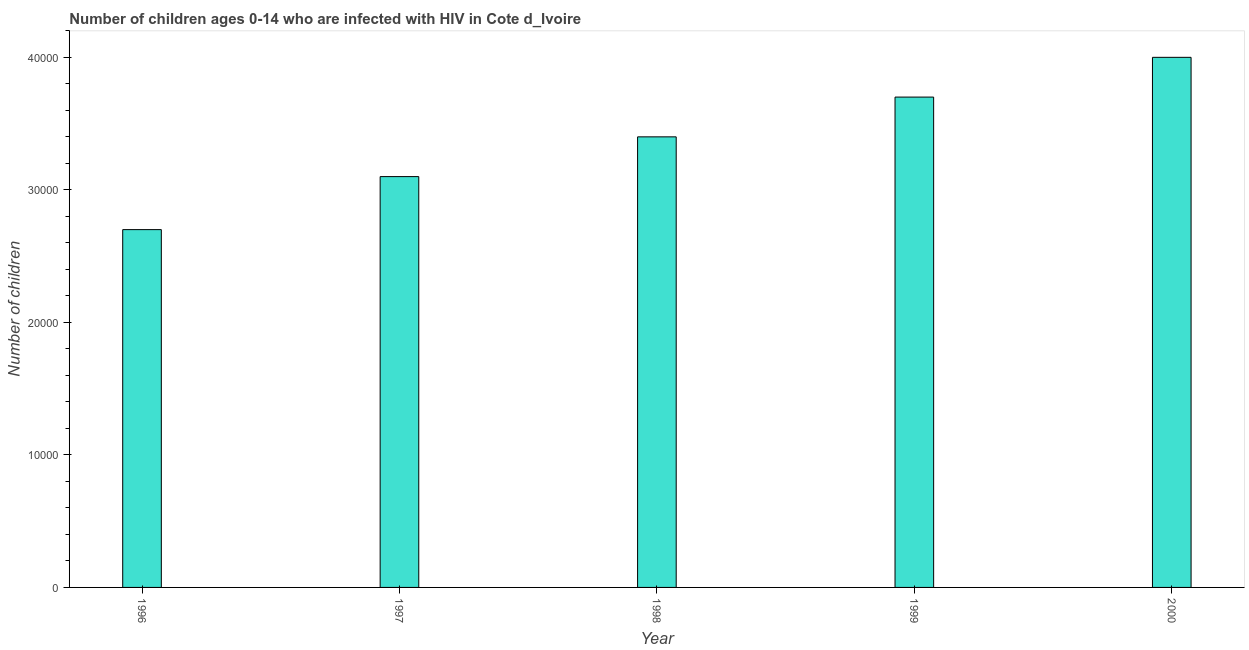Does the graph contain any zero values?
Make the answer very short. No. Does the graph contain grids?
Offer a terse response. No. What is the title of the graph?
Provide a succinct answer. Number of children ages 0-14 who are infected with HIV in Cote d_Ivoire. What is the label or title of the X-axis?
Keep it short and to the point. Year. What is the label or title of the Y-axis?
Provide a succinct answer. Number of children. What is the number of children living with hiv in 1996?
Provide a succinct answer. 2.70e+04. Across all years, what is the maximum number of children living with hiv?
Your response must be concise. 4.00e+04. Across all years, what is the minimum number of children living with hiv?
Make the answer very short. 2.70e+04. In which year was the number of children living with hiv maximum?
Provide a succinct answer. 2000. What is the sum of the number of children living with hiv?
Your response must be concise. 1.69e+05. What is the difference between the number of children living with hiv in 1997 and 2000?
Provide a succinct answer. -9000. What is the average number of children living with hiv per year?
Offer a very short reply. 3.38e+04. What is the median number of children living with hiv?
Provide a succinct answer. 3.40e+04. In how many years, is the number of children living with hiv greater than 4000 ?
Make the answer very short. 5. Do a majority of the years between 1998 and 1996 (inclusive) have number of children living with hiv greater than 32000 ?
Make the answer very short. Yes. What is the ratio of the number of children living with hiv in 1997 to that in 1999?
Provide a succinct answer. 0.84. Is the difference between the number of children living with hiv in 1998 and 1999 greater than the difference between any two years?
Make the answer very short. No. What is the difference between the highest and the second highest number of children living with hiv?
Your answer should be compact. 3000. What is the difference between the highest and the lowest number of children living with hiv?
Your response must be concise. 1.30e+04. Are all the bars in the graph horizontal?
Keep it short and to the point. No. How many years are there in the graph?
Offer a terse response. 5. What is the difference between two consecutive major ticks on the Y-axis?
Give a very brief answer. 10000. What is the Number of children in 1996?
Keep it short and to the point. 2.70e+04. What is the Number of children of 1997?
Make the answer very short. 3.10e+04. What is the Number of children of 1998?
Provide a succinct answer. 3.40e+04. What is the Number of children of 1999?
Ensure brevity in your answer.  3.70e+04. What is the difference between the Number of children in 1996 and 1997?
Ensure brevity in your answer.  -4000. What is the difference between the Number of children in 1996 and 1998?
Make the answer very short. -7000. What is the difference between the Number of children in 1996 and 2000?
Your answer should be compact. -1.30e+04. What is the difference between the Number of children in 1997 and 1998?
Make the answer very short. -3000. What is the difference between the Number of children in 1997 and 1999?
Your answer should be compact. -6000. What is the difference between the Number of children in 1997 and 2000?
Make the answer very short. -9000. What is the difference between the Number of children in 1998 and 1999?
Provide a succinct answer. -3000. What is the difference between the Number of children in 1998 and 2000?
Provide a succinct answer. -6000. What is the difference between the Number of children in 1999 and 2000?
Give a very brief answer. -3000. What is the ratio of the Number of children in 1996 to that in 1997?
Ensure brevity in your answer.  0.87. What is the ratio of the Number of children in 1996 to that in 1998?
Your answer should be very brief. 0.79. What is the ratio of the Number of children in 1996 to that in 1999?
Offer a terse response. 0.73. What is the ratio of the Number of children in 1996 to that in 2000?
Provide a succinct answer. 0.68. What is the ratio of the Number of children in 1997 to that in 1998?
Make the answer very short. 0.91. What is the ratio of the Number of children in 1997 to that in 1999?
Give a very brief answer. 0.84. What is the ratio of the Number of children in 1997 to that in 2000?
Make the answer very short. 0.78. What is the ratio of the Number of children in 1998 to that in 1999?
Offer a terse response. 0.92. What is the ratio of the Number of children in 1998 to that in 2000?
Offer a very short reply. 0.85. What is the ratio of the Number of children in 1999 to that in 2000?
Give a very brief answer. 0.93. 